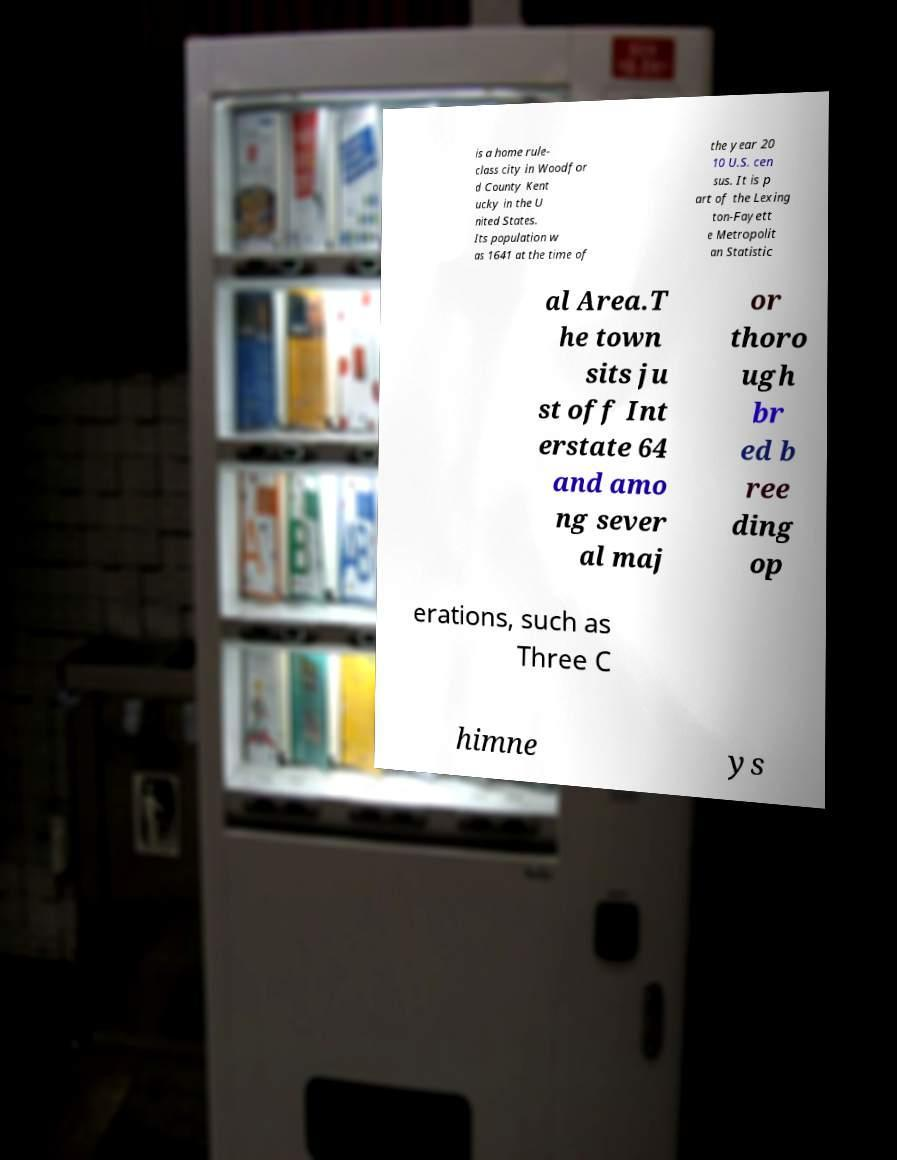There's text embedded in this image that I need extracted. Can you transcribe it verbatim? is a home rule- class city in Woodfor d County Kent ucky in the U nited States. Its population w as 1641 at the time of the year 20 10 U.S. cen sus. It is p art of the Lexing ton-Fayett e Metropolit an Statistic al Area.T he town sits ju st off Int erstate 64 and amo ng sever al maj or thoro ugh br ed b ree ding op erations, such as Three C himne ys 